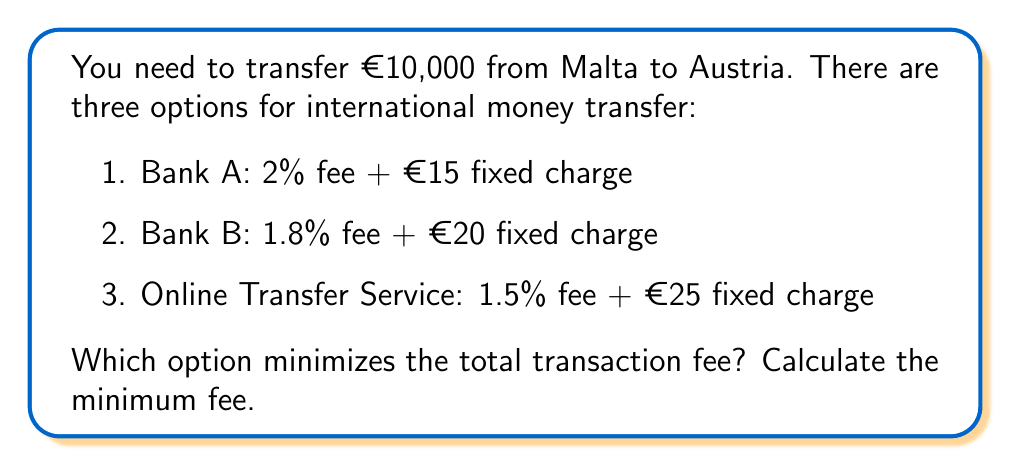Can you solve this math problem? To solve this problem, we need to calculate the total fee for each option and compare them:

1. Bank A:
   Fee = (2% of €10,000) + €15
   $$ Fee_A = (0.02 \times 10000) + 15 = 200 + 15 = €215 $$

2. Bank B:
   Fee = (1.8% of €10,000) + €20
   $$ Fee_B = (0.018 \times 10000) + 20 = 180 + 20 = €200 $$

3. Online Transfer Service:
   Fee = (1.5% of €10,000) + €25
   $$ Fee_C = (0.015 \times 10000) + 25 = 150 + 25 = €175 $$

Comparing the three options:
$$ Fee_C < Fee_B < Fee_A $$

The Online Transfer Service offers the lowest total fee of €175.
Answer: The option that minimizes the total transaction fee is the Online Transfer Service, with a minimum fee of €175. 